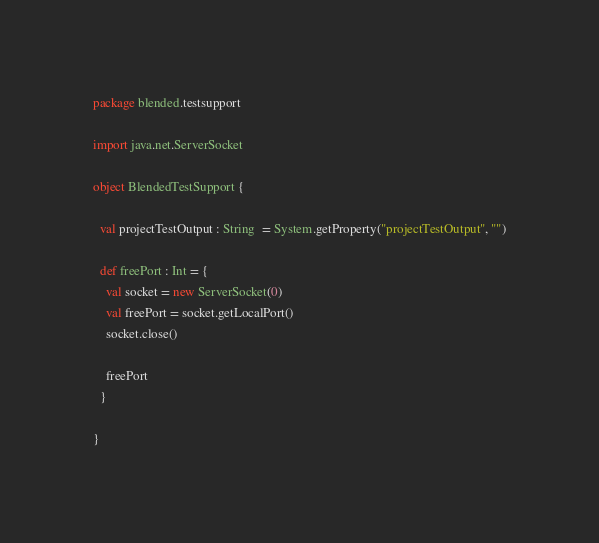<code> <loc_0><loc_0><loc_500><loc_500><_Scala_>package blended.testsupport

import java.net.ServerSocket

object BlendedTestSupport {

  val projectTestOutput : String  = System.getProperty("projectTestOutput", "")

  def freePort : Int = {
    val socket = new ServerSocket(0)
    val freePort = socket.getLocalPort()
    socket.close()

    freePort
  }

}
</code> 